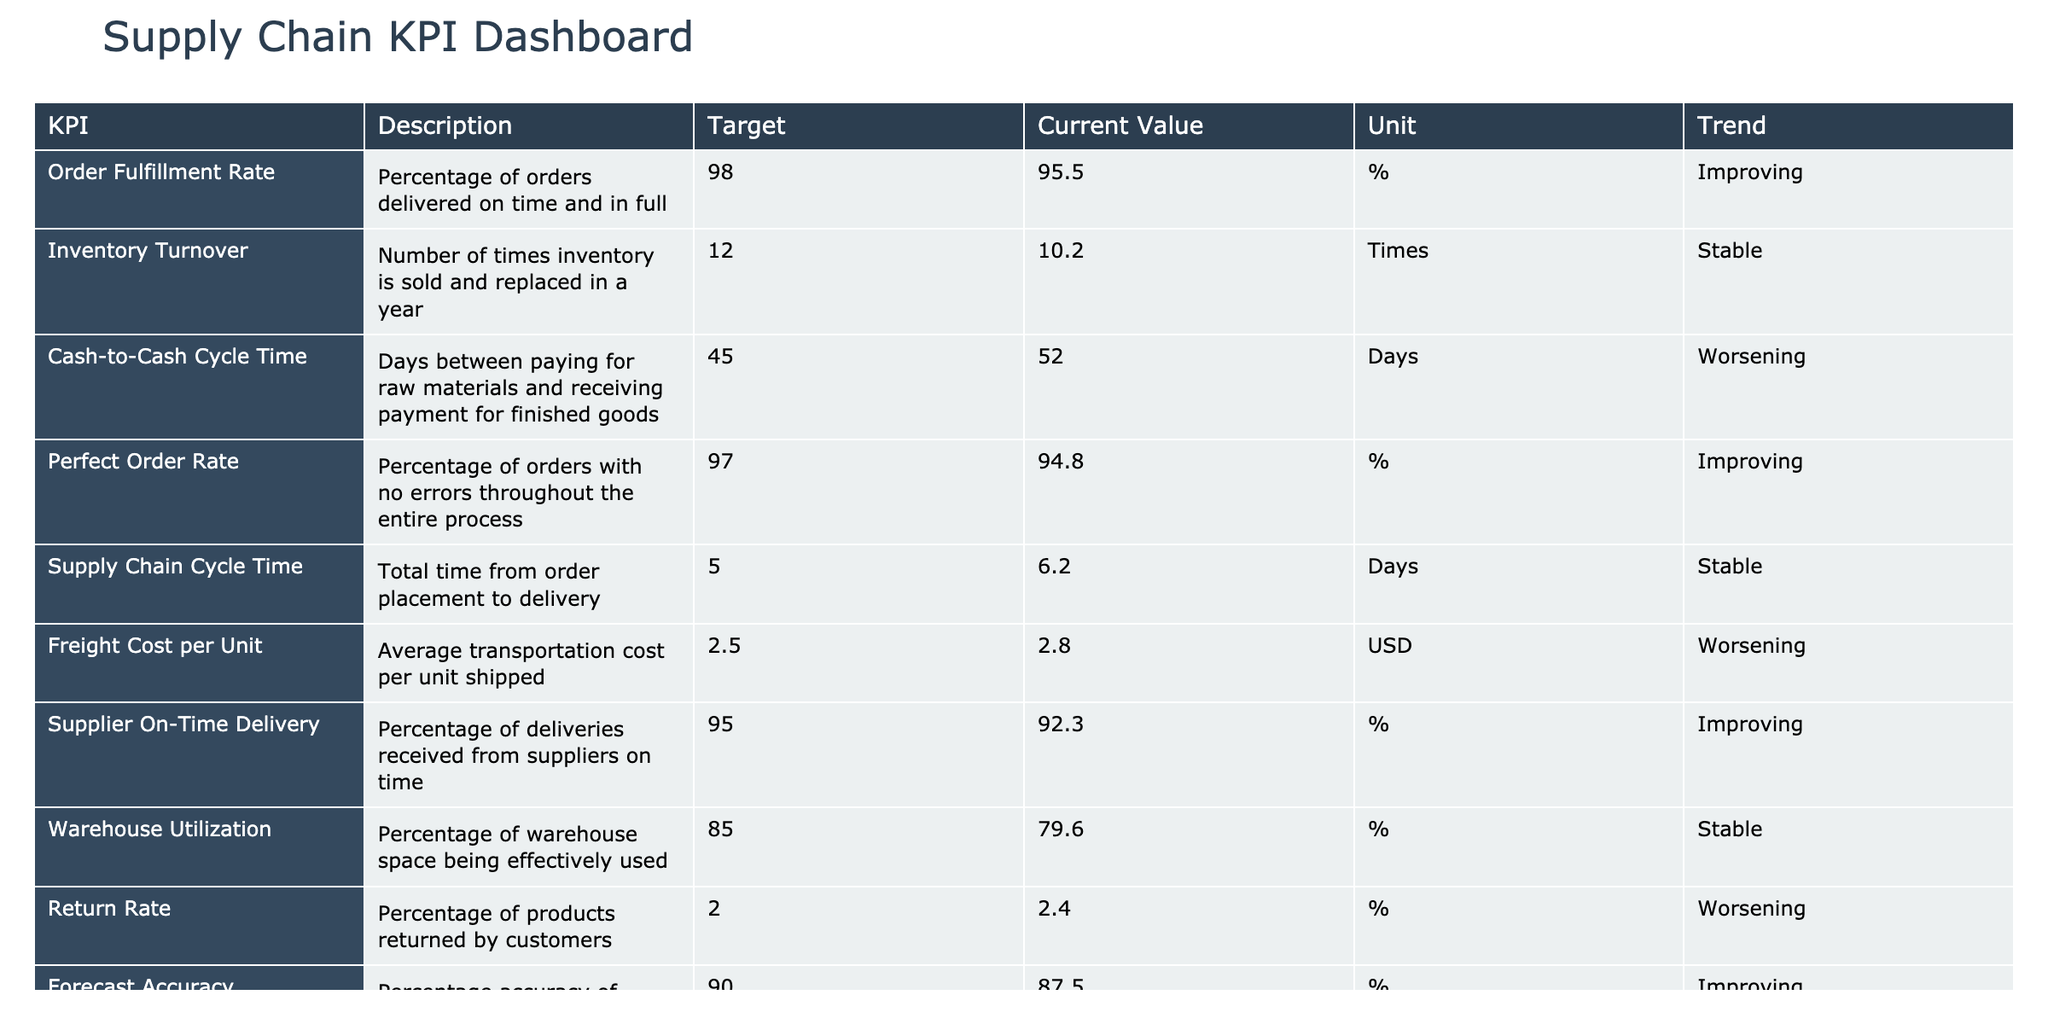What is the current value of the Order Fulfillment Rate? The table shows the "Current Value" for the "Order Fulfillment Rate" as 95.5.
Answer: 95.5 What is the trend for the Inventory Turnover? The trend for the "Inventory Turnover" is marked as "Stable" in the table.
Answer: Stable Is the Perfect Order Rate above its target? The table indicates that the "Perfect Order Rate" is currently 94.8, which is below its target of 97.
Answer: No Calculate the difference between the target and current value of the Cash-to-Cash Cycle Time. The target for the "Cash-to-Cash Cycle Time" is 45 days, and the current value is 52 days. The difference is 52 - 45 = 7 days.
Answer: 7 days What is the average current value for KPIs that have a "Worsening" trend? The current values for the KPIs with a "Worsening" trend are 52 (Cash-to-Cash Cycle Time), 2.8 (Freight Cost per Unit), and 2.4 (Return Rate). The average is (52 + 2.8 + 2.4) / 3 = 19.73.
Answer: 19.73 Does the Warehouse Utilization meet its target? The table shows that the "Warehouse Utilization" is currently at 79.6, which is below the target of 85.
Answer: No What percentage of suppliers are delivering on time according to the Supplier On-Time Delivery KPI? The table displays that the "Supplier On-Time Delivery" is at 92.3%.
Answer: 92.3% Identify any KPI that has an improving trend but is currently below its target. The "Perfect Order Rate" has an improving trend (94.8) but is below its target (97).
Answer: Perfect Order Rate What is the trend for the Return Rate? The table states that the trend for the "Return Rate" is "Worsening."
Answer: Worsening 